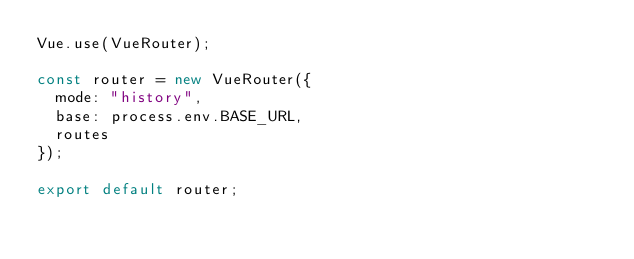Convert code to text. <code><loc_0><loc_0><loc_500><loc_500><_JavaScript_>Vue.use(VueRouter);

const router = new VueRouter({
  mode: "history",
  base: process.env.BASE_URL,
  routes
});

export default router;
</code> 